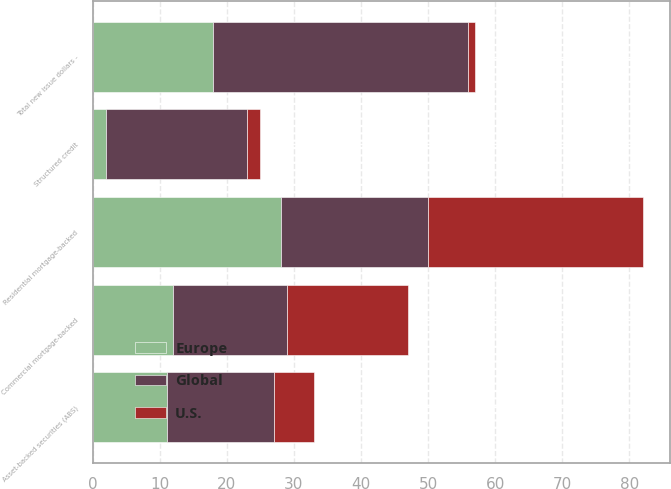<chart> <loc_0><loc_0><loc_500><loc_500><stacked_bar_chart><ecel><fcel>Asset-backed securities (ABS)<fcel>Structured credit<fcel>Commercial mortgage-backed<fcel>Residential mortgage-backed<fcel>Total new issue dollars -<nl><fcel>U.S.<fcel>6<fcel>2<fcel>18<fcel>32<fcel>1<nl><fcel>Global<fcel>16<fcel>21<fcel>17<fcel>22<fcel>38<nl><fcel>Europe<fcel>11<fcel>2<fcel>12<fcel>28<fcel>18<nl></chart> 